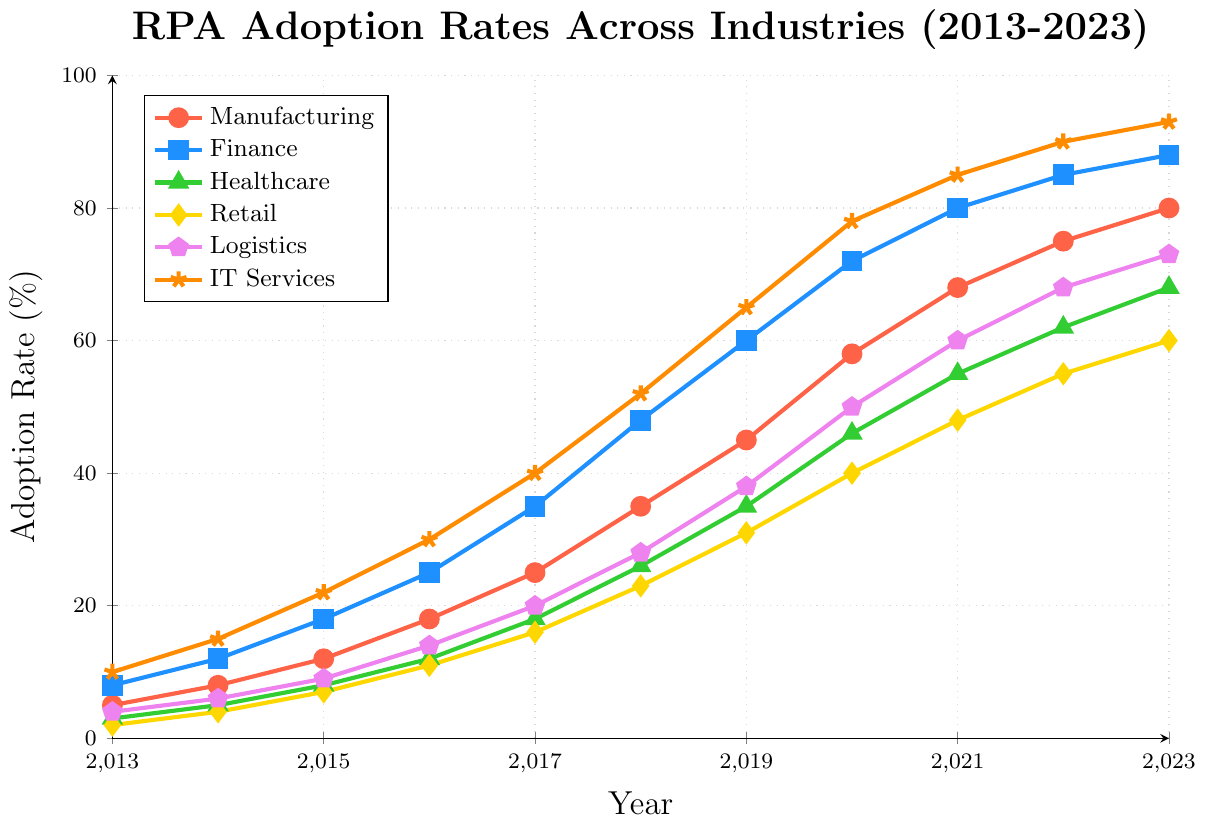How has the adoption rate in the Manufacturing sector changed from 2013 to 2023? Look at the y-values for the Manufacturing sector dateline from 2013 to 2023. The adoption rate increases from 5% in 2013 to 80% in 2023.
Answer: Increased from 5% to 80% Which industry had the highest adoption rate in 2023? Compare the y-values of all the sectors in 2023. IT Services has the highest adoption rate at 93%.
Answer: IT Services What's the difference in the adoption rate between Healthcare and Retail in 2017? Find the y-values for Healthcare and Retail in 2017. Healthcare is at 18% and Retail is at 16%, which gives a difference of \(18\% - 16\% = 2\%\).
Answer: 2% What is the average adoption rate of the IT Services sector from 2013 to 2023? Sum the y-values for IT Services over the years and divide by the number of years. \((10 + 15 + 22 + 30 + 40 + 52 + 65 + 78 + 85 + 90 + 93) / 11 = 56.55\)
Answer: 56.55% In which year did the Logistics sector have a 50% adoption rate? Locate the year on the x-axis where the y-value of the Logistics sector line is 50%. This happens in the year 2020.
Answer: 2020 Compare the growth in adoption rates between Finance and Healthcare from 2013 to 2023. Which sector grew more? Compute the growth for both sectors: Finance: \(88\% - 8\% = 80\%\); Healthcare: \(68\% - 3\% = 65\%\). Finance grew more.
Answer: Finance What is the median adoption rate in the Retail sector over the years? Sort the y-values for Retail and find the middle number in the sorted list. Sorted values: \(2, 4, 7, 11, 16, 23, 31, 40, 48, 55, 60\). Median is 23%.
Answer: 23% How many years did the Manufacturing sector have an adoption rate above 50%? Count the years where the y-value for Manufacturing is greater than 50. This occurs from 2020 to 2023, which is 4 years.
Answer: 4 years Between 2017 and 2020, which sector had the highest increase in adoption rate? Calculate the increase for each sector between 2017 and 2020: 
Manufacturing: \(58\% - 25\% = 33\%\);
Finance: \(72\% - 35\% = 37\%\);
Healthcare: \(46\% - 18\% = 28\%\);
Retail: \(40\% - 16\% = 24\%\);
Logistics: \(50\% - 20\% = 30\%\);
IT Services: \(78\% - 40\% = 38\%\).
IT Services has the highest increase.
Answer: IT Services What minimum adoption rate is achieved by any sector by 2023? Identify the lowest y-value in 2023. Retail has the lowest adoption rate at 60%.
Answer: 60% 